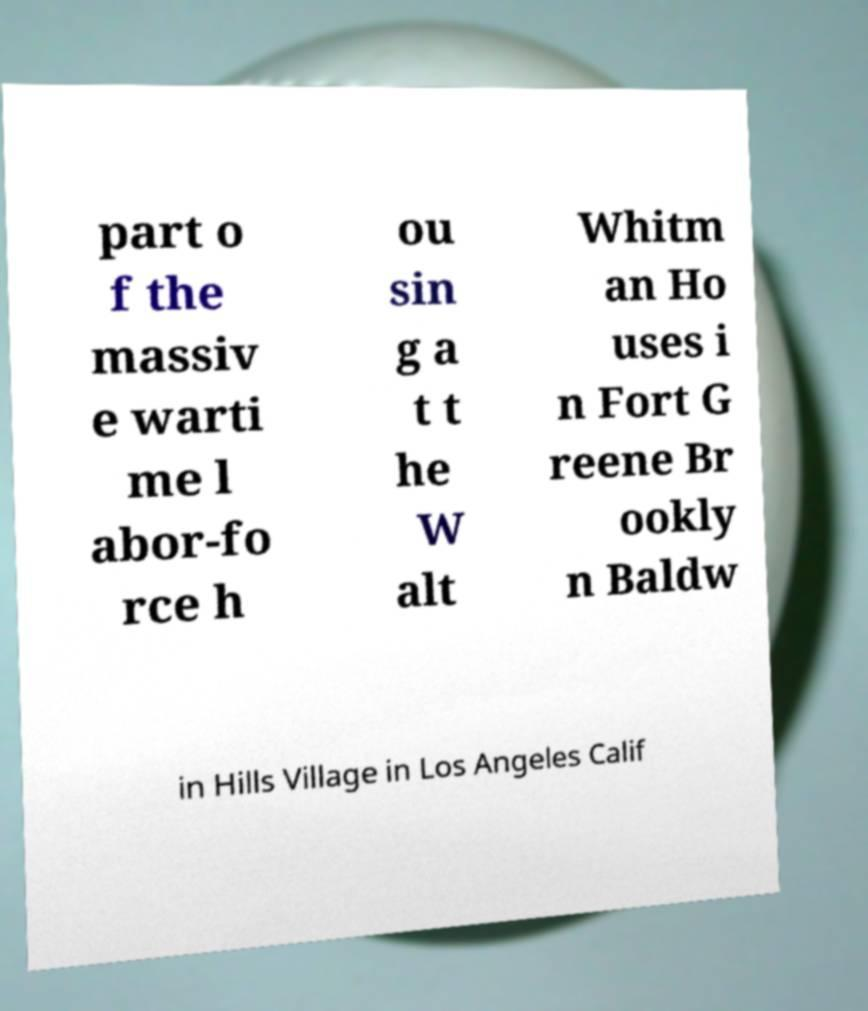Please identify and transcribe the text found in this image. part o f the massiv e warti me l abor-fo rce h ou sin g a t t he W alt Whitm an Ho uses i n Fort G reene Br ookly n Baldw in Hills Village in Los Angeles Calif 